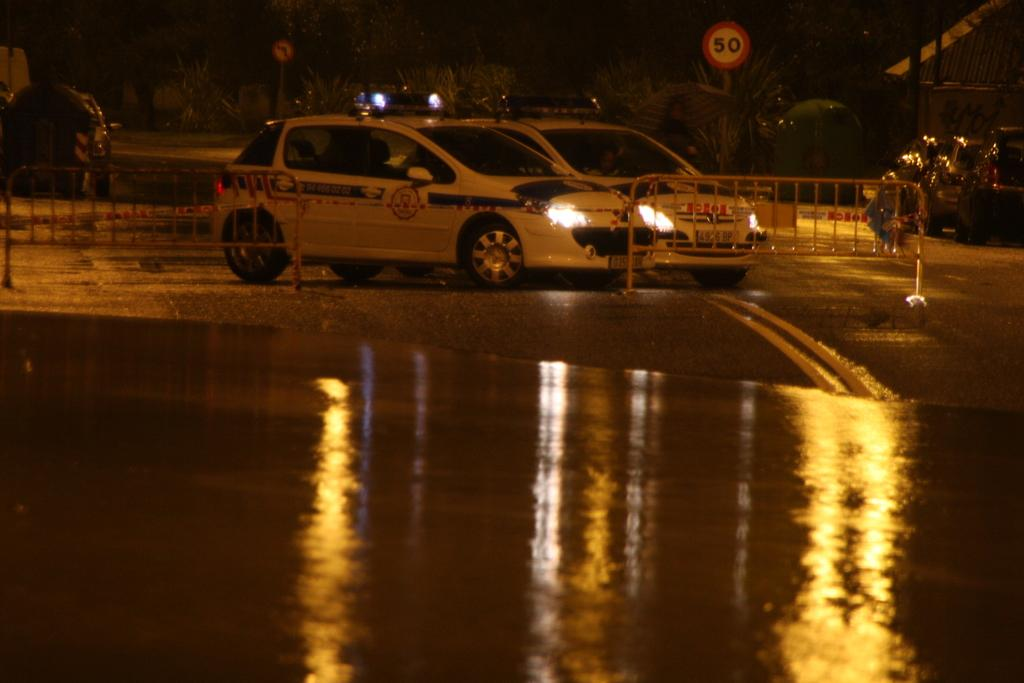What is the main feature of the image? There is a road in the image. What can be seen on the road? There are two vehicles on the road. What else is present in the image besides the road and vehicles? There is a sign board in the image. What can be seen in the background of the image? There are trees in the background of the image. What type of produce is being cooked by the chef in the image? There is no chef or produce present in the image; it features a road, vehicles, a sign board, and trees. What is the zephyr's role in the image? There is no zephyr present in the image; it is a term used to describe a gentle breeze, which is not depicted in the image. 